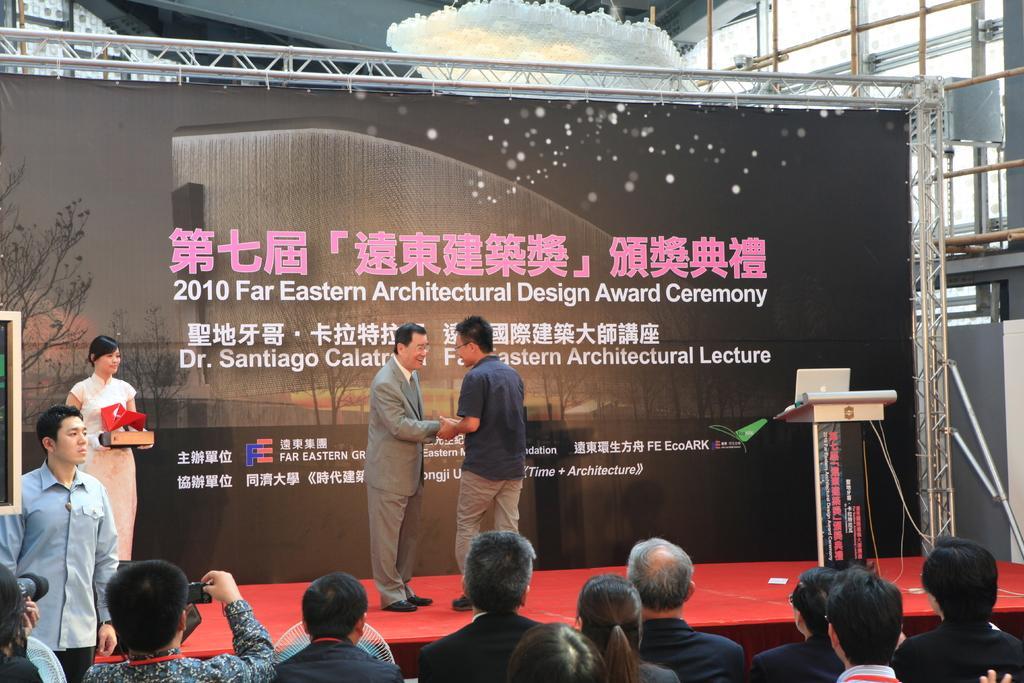In one or two sentences, can you explain what this image depicts? In the center of the image we can see two person are standing and shake handing. At the bottom of the image we can see a group of people are sitting and some of them are holding camera, mobile. On the left side of the image we can see a man is standing and a lady is standing and holding an object. On the right side of the image we can see a podium, on podium we can see laptop. In the background of the image we can see a board, rods. At the top of the image we can see the roof. At the middle of the image we can see a stage. 